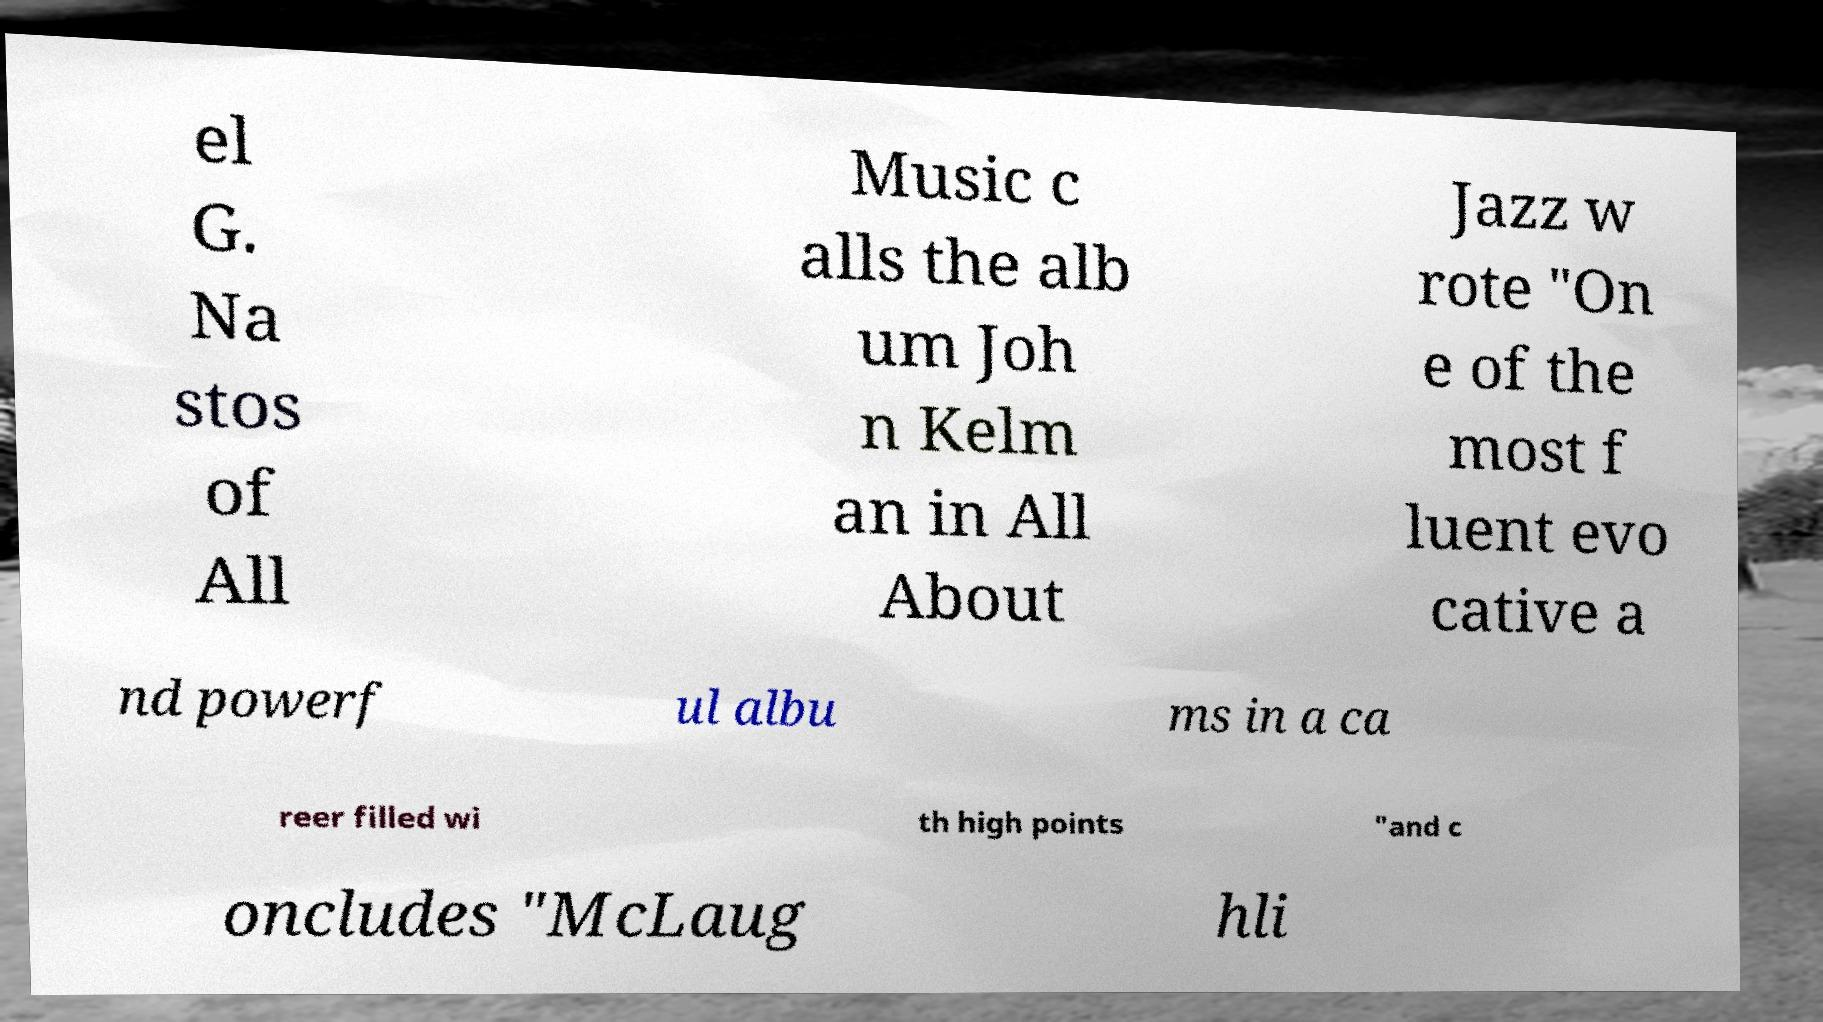For documentation purposes, I need the text within this image transcribed. Could you provide that? el G. Na stos of All Music c alls the alb um Joh n Kelm an in All About Jazz w rote "On e of the most f luent evo cative a nd powerf ul albu ms in a ca reer filled wi th high points "and c oncludes "McLaug hli 